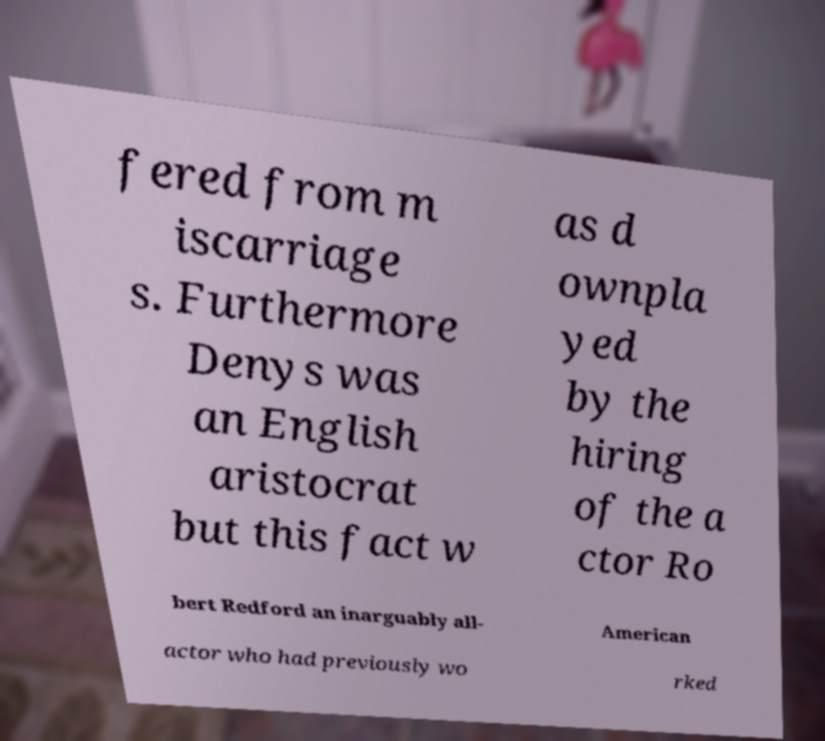Please identify and transcribe the text found in this image. fered from m iscarriage s. Furthermore Denys was an English aristocrat but this fact w as d ownpla yed by the hiring of the a ctor Ro bert Redford an inarguably all- American actor who had previously wo rked 